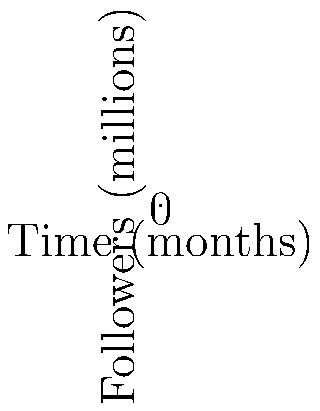The graph above shows the social media follower growth of two K-pop groups over 10 months. Group A's growth is modeled by $f(x) = 0.1x^3 - 1.5x^2 + 7x + 10$, while Group B's growth is modeled by $g(x) = -0.05x^3 + 0.8x^2 - 2x + 15$, where $x$ represents months and $f(x)$ and $g(x)$ represent followers in millions. At which month do both groups have the same number of followers? To find when both groups have the same number of followers, we need to solve the equation:

$f(x) = g(x)$

Substituting the given functions:

$0.1x^3 - 1.5x^2 + 7x + 10 = -0.05x^3 + 0.8x^2 - 2x + 15$

Rearranging terms:

$0.15x^3 - 2.3x^2 + 9x - 5 = 0$

This is a cubic equation. We can solve it by factoring or using the rational root theorem. The solutions are:

$x = 1$ or $x \approx 4.33$ or $x \approx 10.67$

Since we're looking at a 10-month period, the relevant solutions are $x = 1$ and $x \approx 4.33$.

Checking these values:
At $x = 1$: $f(1) = g(1) = 15.6$ million followers
At $x \approx 4.33$: $f(4.33) \approx g(4.33) \approx 25.7$ million followers

Therefore, the groups have the same number of followers at month 1 and around month 4 (more precisely, 4.33).
Answer: Month 1 and Month 4 